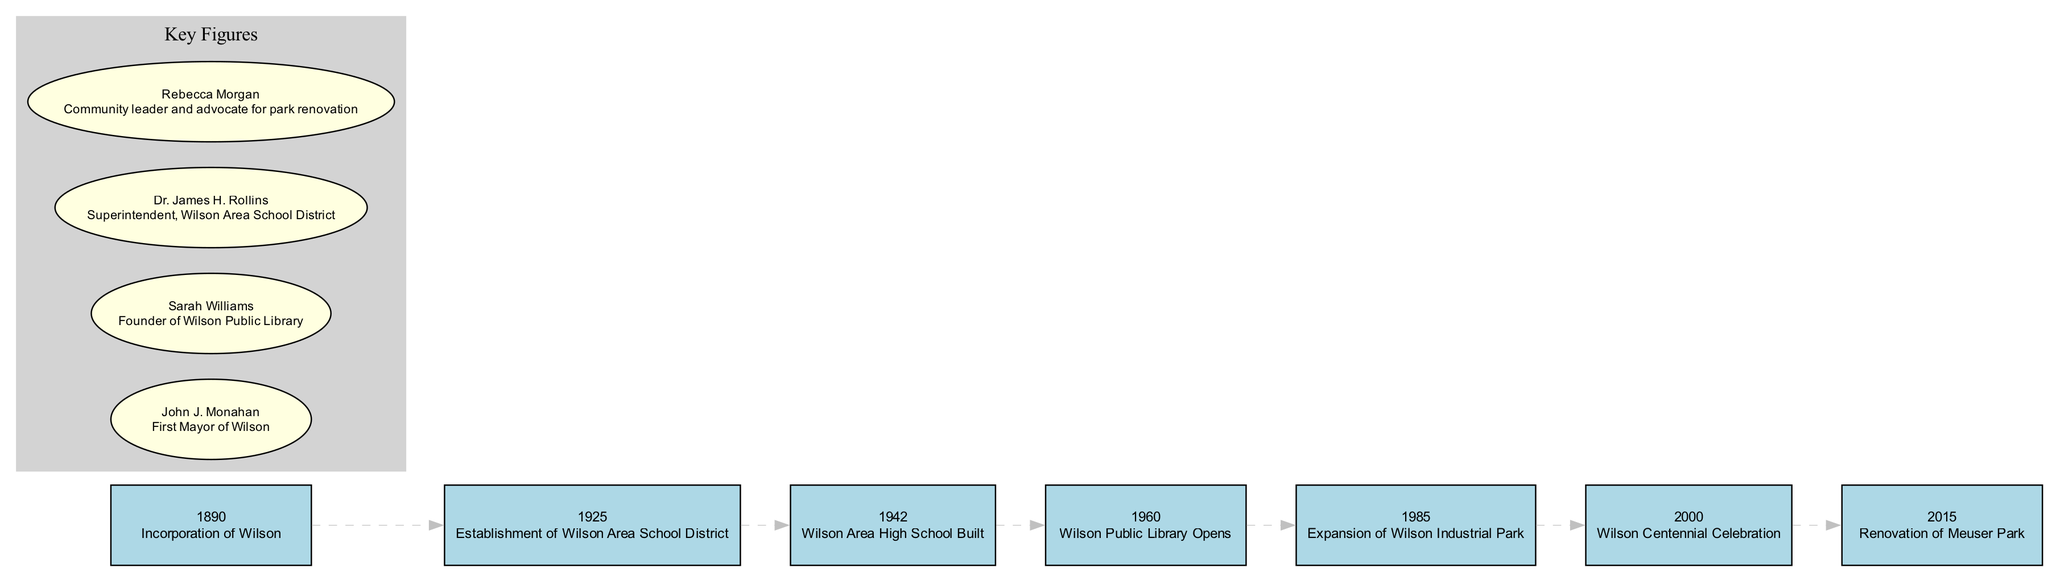What year was Wilson incorporated? The diagram lists the event "Incorporation of Wilson" in the year 1890. Hence, by looking at the specific event, we find that it was officially founded in this year.
Answer: 1890 What event happened in 1960? The diagram shows that in the year 1960, the event "Wilson Public Library Opens" occurred. Hence, we can directly refer to this event for the answer.
Answer: Wilson Public Library Opens Which key figure is associated with the Wilson Public Library? The diagram indicates Sarah Williams as the founder of the Wilson Public Library. To determine this, we check the section labeled 'Key Figures' and find her name connected to this contribution.
Answer: Sarah Williams How many significant events are listed in the timeline? By counting the entries in the timeline section of the diagram, we find there are seven listed events from 1890 to 2015. This involves simply going through each event year and ensuring every listed entry is counted.
Answer: 7 What was the purpose of the 1985 event in the timeline? The event "Expansion of Wilson Industrial Park" in 1985 is clearly marked in the diagram, and its details indicate growth of the local economy and job opportunities, which directly outlines the purpose of the event.
Answer: Growth of local economy and job opportunities Which milestone celebrates 100 years of Wilson Borough? The entry for the year 2000 specifies the event "Wilson Centennial Celebration," indicating that this event celebrates the centennial, or 100 years, of Wilson Borough’s incorporation.
Answer: Wilson Centennial Celebration Who was the first mayor of Wilson? Referring to the 'Key Figures' section in the diagram, John J. Monahan is identified as the first mayor, thus we can directly state this as the answer.
Answer: John J. Monahan What connection does Rebecca Morgan have to the community? In the diagram under 'Key Figures', Rebecca Morgan is described as a community leader and advocate for park renovation, indicating her involvement and significance in local community efforts.
Answer: Community leader and advocate for park renovation Which year saw the establishment of the Wilson Area School District? The timeline indicates that the establishment of the Wilson Area School District occurred in 1925, where it is explicitly mentioned in the details of that specific event.
Answer: 1925 